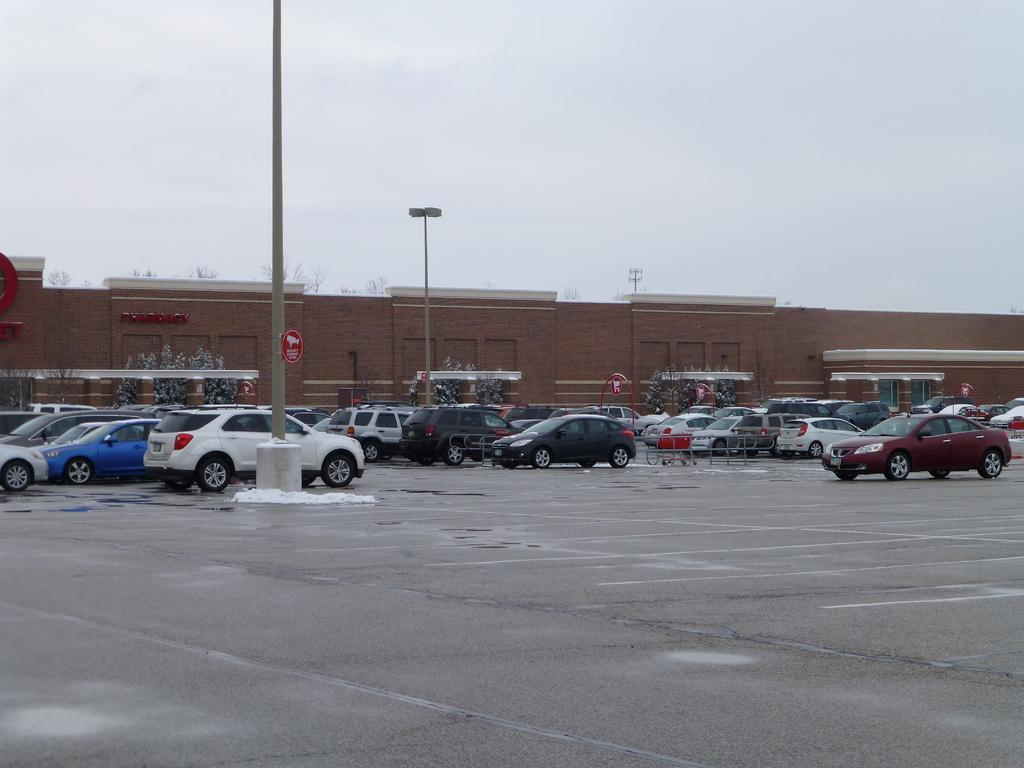What can be seen on the road in the image? There are vehicles parked on the road in the image. What else is present in the image besides the parked vehicles? There are signboards, poles, trees, and a wall in the image. What is visible in the background of the image? The sky is visible in the background of the image. Can you tell me how many matches are being used to create the art in the image? There is no art or matches present in the image; it features vehicles parked on the road, signboards, poles, trees, a wall, and the sky in the background. 